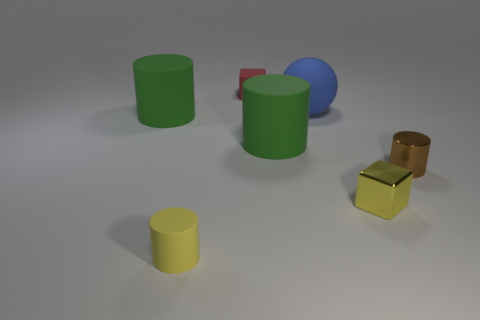Does the green cylinder that is left of the red rubber object have the same size as the blue object?
Offer a terse response. Yes. Is there a small cylinder of the same color as the small metallic block?
Offer a very short reply. Yes. Are there any tiny red rubber cubes to the right of the large green object that is to the right of the yellow matte cylinder?
Your response must be concise. No. Are there any green cylinders made of the same material as the red cube?
Provide a succinct answer. Yes. What is the tiny cylinder on the right side of the blue matte sphere on the left side of the brown shiny thing made of?
Offer a very short reply. Metal. There is a thing that is right of the red object and in front of the small metallic cylinder; what is it made of?
Your response must be concise. Metal. Are there an equal number of large green things that are left of the red matte block and yellow metallic things?
Provide a succinct answer. Yes. How many tiny things are the same shape as the big blue rubber object?
Your answer should be compact. 0. There is a green matte thing behind the large green matte cylinder on the right side of the small yellow thing that is to the left of the large blue ball; what size is it?
Give a very brief answer. Large. Does the block on the right side of the blue matte thing have the same material as the big blue thing?
Give a very brief answer. No. 